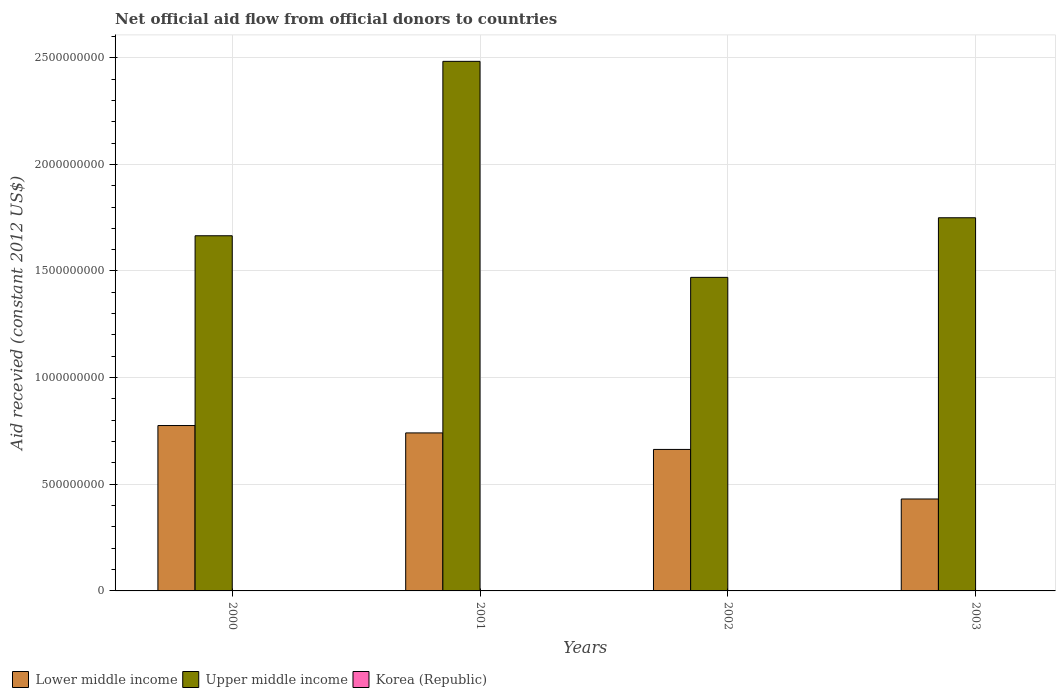How many different coloured bars are there?
Offer a very short reply. 2. Are the number of bars per tick equal to the number of legend labels?
Provide a succinct answer. No. Are the number of bars on each tick of the X-axis equal?
Provide a succinct answer. Yes. What is the label of the 3rd group of bars from the left?
Offer a very short reply. 2002. What is the total aid received in Upper middle income in 2000?
Offer a very short reply. 1.67e+09. Across all years, what is the maximum total aid received in Upper middle income?
Your response must be concise. 2.48e+09. Across all years, what is the minimum total aid received in Upper middle income?
Give a very brief answer. 1.47e+09. In which year was the total aid received in Lower middle income maximum?
Provide a succinct answer. 2000. What is the total total aid received in Lower middle income in the graph?
Give a very brief answer. 2.61e+09. What is the difference between the total aid received in Upper middle income in 2000 and that in 2002?
Keep it short and to the point. 1.95e+08. What is the difference between the total aid received in Lower middle income in 2003 and the total aid received in Korea (Republic) in 2001?
Offer a terse response. 4.31e+08. What is the average total aid received in Lower middle income per year?
Give a very brief answer. 6.53e+08. In the year 2002, what is the difference between the total aid received in Upper middle income and total aid received in Lower middle income?
Your answer should be compact. 8.07e+08. In how many years, is the total aid received in Upper middle income greater than 700000000 US$?
Keep it short and to the point. 4. What is the ratio of the total aid received in Upper middle income in 2002 to that in 2003?
Make the answer very short. 0.84. Is the total aid received in Upper middle income in 2000 less than that in 2002?
Provide a short and direct response. No. Is the difference between the total aid received in Upper middle income in 2001 and 2002 greater than the difference between the total aid received in Lower middle income in 2001 and 2002?
Your response must be concise. Yes. What is the difference between the highest and the second highest total aid received in Upper middle income?
Give a very brief answer. 7.33e+08. What is the difference between the highest and the lowest total aid received in Lower middle income?
Make the answer very short. 3.44e+08. Is it the case that in every year, the sum of the total aid received in Korea (Republic) and total aid received in Upper middle income is greater than the total aid received in Lower middle income?
Provide a short and direct response. Yes. Does the graph contain any zero values?
Give a very brief answer. Yes. What is the title of the graph?
Make the answer very short. Net official aid flow from official donors to countries. What is the label or title of the Y-axis?
Make the answer very short. Aid recevied (constant 2012 US$). What is the Aid recevied (constant 2012 US$) of Lower middle income in 2000?
Provide a succinct answer. 7.75e+08. What is the Aid recevied (constant 2012 US$) of Upper middle income in 2000?
Keep it short and to the point. 1.67e+09. What is the Aid recevied (constant 2012 US$) in Lower middle income in 2001?
Your answer should be very brief. 7.41e+08. What is the Aid recevied (constant 2012 US$) in Upper middle income in 2001?
Offer a very short reply. 2.48e+09. What is the Aid recevied (constant 2012 US$) of Lower middle income in 2002?
Provide a succinct answer. 6.63e+08. What is the Aid recevied (constant 2012 US$) of Upper middle income in 2002?
Ensure brevity in your answer.  1.47e+09. What is the Aid recevied (constant 2012 US$) in Korea (Republic) in 2002?
Keep it short and to the point. 0. What is the Aid recevied (constant 2012 US$) in Lower middle income in 2003?
Your answer should be compact. 4.31e+08. What is the Aid recevied (constant 2012 US$) of Upper middle income in 2003?
Your response must be concise. 1.75e+09. Across all years, what is the maximum Aid recevied (constant 2012 US$) in Lower middle income?
Provide a short and direct response. 7.75e+08. Across all years, what is the maximum Aid recevied (constant 2012 US$) in Upper middle income?
Offer a very short reply. 2.48e+09. Across all years, what is the minimum Aid recevied (constant 2012 US$) in Lower middle income?
Offer a very short reply. 4.31e+08. Across all years, what is the minimum Aid recevied (constant 2012 US$) in Upper middle income?
Offer a terse response. 1.47e+09. What is the total Aid recevied (constant 2012 US$) of Lower middle income in the graph?
Your response must be concise. 2.61e+09. What is the total Aid recevied (constant 2012 US$) in Upper middle income in the graph?
Your answer should be very brief. 7.37e+09. What is the difference between the Aid recevied (constant 2012 US$) in Lower middle income in 2000 and that in 2001?
Your response must be concise. 3.46e+07. What is the difference between the Aid recevied (constant 2012 US$) of Upper middle income in 2000 and that in 2001?
Make the answer very short. -8.18e+08. What is the difference between the Aid recevied (constant 2012 US$) in Lower middle income in 2000 and that in 2002?
Offer a terse response. 1.12e+08. What is the difference between the Aid recevied (constant 2012 US$) in Upper middle income in 2000 and that in 2002?
Keep it short and to the point. 1.95e+08. What is the difference between the Aid recevied (constant 2012 US$) in Lower middle income in 2000 and that in 2003?
Your response must be concise. 3.44e+08. What is the difference between the Aid recevied (constant 2012 US$) in Upper middle income in 2000 and that in 2003?
Your answer should be compact. -8.44e+07. What is the difference between the Aid recevied (constant 2012 US$) of Lower middle income in 2001 and that in 2002?
Your answer should be very brief. 7.75e+07. What is the difference between the Aid recevied (constant 2012 US$) of Upper middle income in 2001 and that in 2002?
Ensure brevity in your answer.  1.01e+09. What is the difference between the Aid recevied (constant 2012 US$) of Lower middle income in 2001 and that in 2003?
Your response must be concise. 3.10e+08. What is the difference between the Aid recevied (constant 2012 US$) of Upper middle income in 2001 and that in 2003?
Keep it short and to the point. 7.33e+08. What is the difference between the Aid recevied (constant 2012 US$) in Lower middle income in 2002 and that in 2003?
Provide a succinct answer. 2.32e+08. What is the difference between the Aid recevied (constant 2012 US$) of Upper middle income in 2002 and that in 2003?
Keep it short and to the point. -2.79e+08. What is the difference between the Aid recevied (constant 2012 US$) of Lower middle income in 2000 and the Aid recevied (constant 2012 US$) of Upper middle income in 2001?
Make the answer very short. -1.71e+09. What is the difference between the Aid recevied (constant 2012 US$) of Lower middle income in 2000 and the Aid recevied (constant 2012 US$) of Upper middle income in 2002?
Your answer should be compact. -6.95e+08. What is the difference between the Aid recevied (constant 2012 US$) of Lower middle income in 2000 and the Aid recevied (constant 2012 US$) of Upper middle income in 2003?
Keep it short and to the point. -9.74e+08. What is the difference between the Aid recevied (constant 2012 US$) of Lower middle income in 2001 and the Aid recevied (constant 2012 US$) of Upper middle income in 2002?
Provide a short and direct response. -7.29e+08. What is the difference between the Aid recevied (constant 2012 US$) of Lower middle income in 2001 and the Aid recevied (constant 2012 US$) of Upper middle income in 2003?
Offer a very short reply. -1.01e+09. What is the difference between the Aid recevied (constant 2012 US$) of Lower middle income in 2002 and the Aid recevied (constant 2012 US$) of Upper middle income in 2003?
Offer a terse response. -1.09e+09. What is the average Aid recevied (constant 2012 US$) in Lower middle income per year?
Your answer should be compact. 6.53e+08. What is the average Aid recevied (constant 2012 US$) in Upper middle income per year?
Your answer should be compact. 1.84e+09. What is the average Aid recevied (constant 2012 US$) in Korea (Republic) per year?
Offer a very short reply. 0. In the year 2000, what is the difference between the Aid recevied (constant 2012 US$) in Lower middle income and Aid recevied (constant 2012 US$) in Upper middle income?
Offer a very short reply. -8.90e+08. In the year 2001, what is the difference between the Aid recevied (constant 2012 US$) in Lower middle income and Aid recevied (constant 2012 US$) in Upper middle income?
Your response must be concise. -1.74e+09. In the year 2002, what is the difference between the Aid recevied (constant 2012 US$) of Lower middle income and Aid recevied (constant 2012 US$) of Upper middle income?
Offer a very short reply. -8.07e+08. In the year 2003, what is the difference between the Aid recevied (constant 2012 US$) of Lower middle income and Aid recevied (constant 2012 US$) of Upper middle income?
Your response must be concise. -1.32e+09. What is the ratio of the Aid recevied (constant 2012 US$) in Lower middle income in 2000 to that in 2001?
Give a very brief answer. 1.05. What is the ratio of the Aid recevied (constant 2012 US$) of Upper middle income in 2000 to that in 2001?
Provide a short and direct response. 0.67. What is the ratio of the Aid recevied (constant 2012 US$) in Lower middle income in 2000 to that in 2002?
Your response must be concise. 1.17. What is the ratio of the Aid recevied (constant 2012 US$) in Upper middle income in 2000 to that in 2002?
Give a very brief answer. 1.13. What is the ratio of the Aid recevied (constant 2012 US$) in Lower middle income in 2000 to that in 2003?
Your answer should be compact. 1.8. What is the ratio of the Aid recevied (constant 2012 US$) of Upper middle income in 2000 to that in 2003?
Your answer should be compact. 0.95. What is the ratio of the Aid recevied (constant 2012 US$) in Lower middle income in 2001 to that in 2002?
Your answer should be very brief. 1.12. What is the ratio of the Aid recevied (constant 2012 US$) of Upper middle income in 2001 to that in 2002?
Your response must be concise. 1.69. What is the ratio of the Aid recevied (constant 2012 US$) of Lower middle income in 2001 to that in 2003?
Keep it short and to the point. 1.72. What is the ratio of the Aid recevied (constant 2012 US$) in Upper middle income in 2001 to that in 2003?
Ensure brevity in your answer.  1.42. What is the ratio of the Aid recevied (constant 2012 US$) of Lower middle income in 2002 to that in 2003?
Ensure brevity in your answer.  1.54. What is the ratio of the Aid recevied (constant 2012 US$) of Upper middle income in 2002 to that in 2003?
Make the answer very short. 0.84. What is the difference between the highest and the second highest Aid recevied (constant 2012 US$) in Lower middle income?
Your answer should be compact. 3.46e+07. What is the difference between the highest and the second highest Aid recevied (constant 2012 US$) of Upper middle income?
Keep it short and to the point. 7.33e+08. What is the difference between the highest and the lowest Aid recevied (constant 2012 US$) in Lower middle income?
Keep it short and to the point. 3.44e+08. What is the difference between the highest and the lowest Aid recevied (constant 2012 US$) in Upper middle income?
Offer a very short reply. 1.01e+09. 